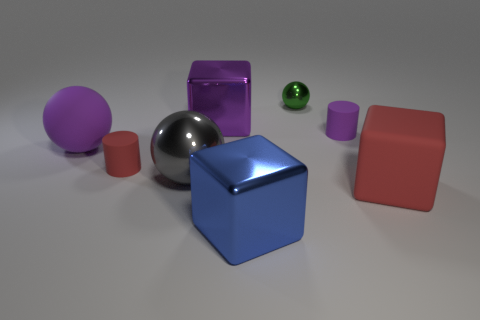How big is the red rubber thing on the left side of the big red rubber block?
Keep it short and to the point. Small. There is a tiny matte object that is behind the big matte object that is behind the red matte block; what is its shape?
Offer a terse response. Cylinder. What is the color of the small object that is the same shape as the large gray shiny thing?
Provide a short and direct response. Green. There is a object that is in front of the rubber block; does it have the same size as the big red rubber cube?
Your answer should be very brief. Yes. What is the shape of the small thing that is the same color as the big matte sphere?
Your answer should be very brief. Cylinder. What number of blue cubes have the same material as the large red block?
Keep it short and to the point. 0. What material is the thing on the left side of the red rubber thing behind the large rubber object that is to the right of the purple block?
Give a very brief answer. Rubber. What color is the big matte object in front of the red matte thing that is left of the large blue block?
Offer a terse response. Red. The rubber ball that is the same size as the gray shiny sphere is what color?
Provide a short and direct response. Purple. How many large things are purple cylinders or yellow matte spheres?
Your answer should be compact. 0. 